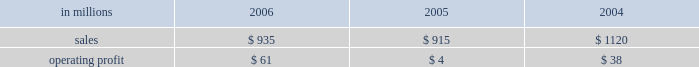Will no longer be significant contributors to business operating results , while expenses should also decline significantly reflecting the reduced level of operations .
Operating earnings will primarily consist of retail forestland and real estate sales of remaining acreage .
Specialty businesses and other the specialty businesses and other segment includes the results of the arizona chemical business and certain divested businesses whose results are included in this segment for periods prior to their sale or closure .
This segment 2019s 2006 net sales increased 2% ( 2 % ) from 2005 , but declined 17% ( 17 % ) from 2004 .
Operating profits in 2006 were up substantially from both 2005 and 2004 .
The decline in sales compared with 2004 principally reflects declining contributions from businesses sold or closed .
Specialty businesses and other in millions 2006 2005 2004 .
Arizona chemical sales were $ 769 million in 2006 , compared with $ 692 million in 2005 and $ 672 million in 2004 .
Sales volumes declined in 2006 compared with 2005 , but average sales price realiza- tions in 2006 were higher in both the united states and europe .
Operating earnings in 2006 were sig- nificantly higher than in 2005 and more than 49% ( 49 % ) higher than in 2004 .
The increase over 2005 reflects the impact of the higher average sales price realiza- tions and lower manufacturing costs , partially offset by higher prices for crude tall oil ( cto ) .
Earnings for 2005 also included a $ 13 million charge related to a plant shutdown in norway .
Other businesses in this operating segment include operations that have been sold , closed or held for sale , primarily the polyrey business in france and , in prior years , the european distribution business .
Sales for these businesses were approximately $ 166 million in 2006 , compared with $ 223 million in 2005 and $ 448 million in 2004 .
In december 2006 , the company entered into a definitive agreement to sell the arizona chemical business , expected to close in the first quarter of liquidity and capital resources overview a major factor in international paper 2019s liquidity and capital resource planning is its generation of operat- ing cash flow , which is highly sensitive to changes in the pricing and demand for our major products .
While changes in key cash operating costs , such as energy and raw material costs , do have an effect on operating cash generation , we believe that our strong focus on cost controls has improved our cash flow generation over an operating cycle .
As part of the continuing focus on improving our return on investment , we have focused our capital spending on improving our key paper and packaging businesses both globally and in north america .
Spending levels have been kept below the level of depreciation and amortization charges for each of the last three years , and we anticipate spending will again be slightly below depreciation and amor- tization in 2007 .
Financing activities in 2006 have been focused on the transformation plan objective of strengthening the balance sheet through repayment of debt , resulting in a net reduction in 2006 of $ 5.2 billion following a $ 1.7 billion net reduction in 2005 .
Additionally , we made a $ 1.0 billion voluntary cash contribution to our u.s .
Qualified pension plan in december 2006 to begin satisfying projected long-term funding requirements and to lower future pension expense .
Our liquidity position continues to be strong , with approximately $ 3.0 billion of committed liquidity to cover future short-term cash flow requirements not met by operating cash flows .
Management believes it is important for interna- tional paper to maintain an investment-grade credit rating to facilitate access to capital markets on favorable terms .
At december 31 , 2006 , the com- pany held long-term credit ratings of bbb ( stable outlook ) and baa3 ( stable outlook ) from standard & poor 2019s and moody 2019s investor services , respectively .
Cash provided by operations cash provided by continuing operations totaled $ 1.0 billion for 2006 , compared with $ 1.2 billion for 2005 and $ 1.7 billion in 2004 .
The 2006 amount is net of a $ 1.0 billion voluntary cash pension plan contribution made in the fourth quarter of 2006 .
The major components of cash provided by continuing oper- ations are earnings from continuing operations .
What was the average cash provided by the continuing operations from 2004 to 2006 in billions? 
Computations: (((1 + 1.2) / 1.7) / 3)
Answer: 0.43137. 